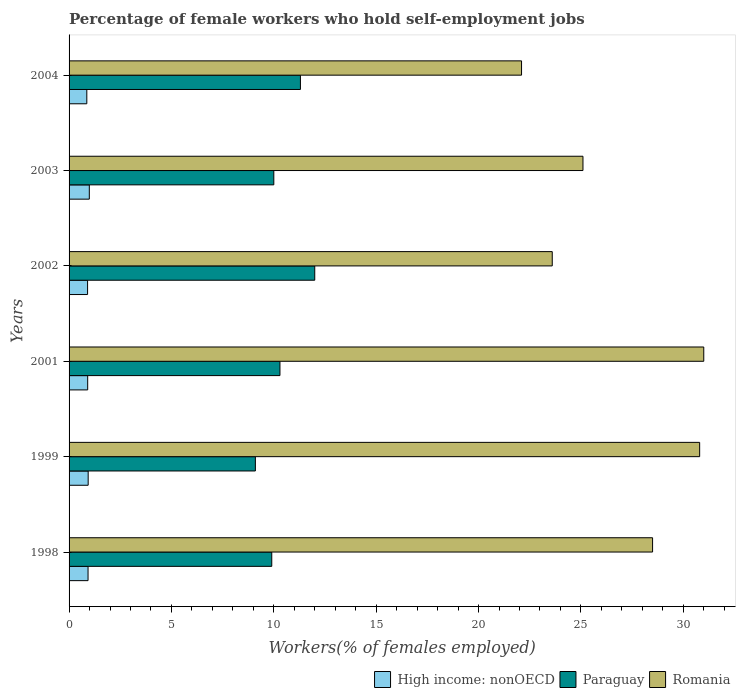Are the number of bars per tick equal to the number of legend labels?
Provide a short and direct response. Yes. How many bars are there on the 4th tick from the top?
Offer a very short reply. 3. What is the label of the 2nd group of bars from the top?
Offer a terse response. 2003. What is the percentage of self-employed female workers in Paraguay in 1999?
Provide a succinct answer. 9.1. Across all years, what is the maximum percentage of self-employed female workers in High income: nonOECD?
Give a very brief answer. 0.99. Across all years, what is the minimum percentage of self-employed female workers in High income: nonOECD?
Keep it short and to the point. 0.87. In which year was the percentage of self-employed female workers in Paraguay maximum?
Keep it short and to the point. 2002. What is the total percentage of self-employed female workers in Romania in the graph?
Offer a terse response. 161.1. What is the difference between the percentage of self-employed female workers in High income: nonOECD in 2002 and that in 2004?
Your answer should be compact. 0.04. What is the difference between the percentage of self-employed female workers in Paraguay in 1999 and the percentage of self-employed female workers in High income: nonOECD in 2001?
Your answer should be very brief. 8.19. What is the average percentage of self-employed female workers in High income: nonOECD per year?
Provide a succinct answer. 0.92. In the year 2003, what is the difference between the percentage of self-employed female workers in High income: nonOECD and percentage of self-employed female workers in Paraguay?
Your response must be concise. -9.01. In how many years, is the percentage of self-employed female workers in Romania greater than 18 %?
Offer a very short reply. 6. What is the ratio of the percentage of self-employed female workers in Paraguay in 1999 to that in 2003?
Offer a terse response. 0.91. What is the difference between the highest and the second highest percentage of self-employed female workers in Paraguay?
Your response must be concise. 0.7. What is the difference between the highest and the lowest percentage of self-employed female workers in Romania?
Your answer should be compact. 8.9. In how many years, is the percentage of self-employed female workers in Paraguay greater than the average percentage of self-employed female workers in Paraguay taken over all years?
Your answer should be very brief. 2. Is the sum of the percentage of self-employed female workers in High income: nonOECD in 2002 and 2003 greater than the maximum percentage of self-employed female workers in Paraguay across all years?
Offer a terse response. No. What does the 1st bar from the top in 2004 represents?
Your answer should be very brief. Romania. What does the 1st bar from the bottom in 1998 represents?
Give a very brief answer. High income: nonOECD. Is it the case that in every year, the sum of the percentage of self-employed female workers in Romania and percentage of self-employed female workers in Paraguay is greater than the percentage of self-employed female workers in High income: nonOECD?
Give a very brief answer. Yes. How many bars are there?
Keep it short and to the point. 18. Are all the bars in the graph horizontal?
Make the answer very short. Yes. What is the difference between two consecutive major ticks on the X-axis?
Your response must be concise. 5. Does the graph contain any zero values?
Give a very brief answer. No. Does the graph contain grids?
Provide a succinct answer. No. How many legend labels are there?
Make the answer very short. 3. How are the legend labels stacked?
Provide a short and direct response. Horizontal. What is the title of the graph?
Provide a succinct answer. Percentage of female workers who hold self-employment jobs. What is the label or title of the X-axis?
Provide a succinct answer. Workers(% of females employed). What is the label or title of the Y-axis?
Give a very brief answer. Years. What is the Workers(% of females employed) of High income: nonOECD in 1998?
Your answer should be compact. 0.93. What is the Workers(% of females employed) in Paraguay in 1998?
Offer a very short reply. 9.9. What is the Workers(% of females employed) in Romania in 1998?
Keep it short and to the point. 28.5. What is the Workers(% of females employed) of High income: nonOECD in 1999?
Make the answer very short. 0.93. What is the Workers(% of females employed) in Paraguay in 1999?
Make the answer very short. 9.1. What is the Workers(% of females employed) of Romania in 1999?
Ensure brevity in your answer.  30.8. What is the Workers(% of females employed) of High income: nonOECD in 2001?
Offer a very short reply. 0.91. What is the Workers(% of females employed) of Paraguay in 2001?
Make the answer very short. 10.3. What is the Workers(% of females employed) in High income: nonOECD in 2002?
Ensure brevity in your answer.  0.9. What is the Workers(% of females employed) in Romania in 2002?
Offer a terse response. 23.6. What is the Workers(% of females employed) of High income: nonOECD in 2003?
Your response must be concise. 0.99. What is the Workers(% of females employed) of Paraguay in 2003?
Your answer should be very brief. 10. What is the Workers(% of females employed) of Romania in 2003?
Ensure brevity in your answer.  25.1. What is the Workers(% of females employed) of High income: nonOECD in 2004?
Your answer should be very brief. 0.87. What is the Workers(% of females employed) of Paraguay in 2004?
Give a very brief answer. 11.3. What is the Workers(% of females employed) in Romania in 2004?
Keep it short and to the point. 22.1. Across all years, what is the maximum Workers(% of females employed) in High income: nonOECD?
Give a very brief answer. 0.99. Across all years, what is the maximum Workers(% of females employed) in Paraguay?
Your response must be concise. 12. Across all years, what is the maximum Workers(% of females employed) in Romania?
Provide a succinct answer. 31. Across all years, what is the minimum Workers(% of females employed) in High income: nonOECD?
Provide a succinct answer. 0.87. Across all years, what is the minimum Workers(% of females employed) in Paraguay?
Your answer should be compact. 9.1. Across all years, what is the minimum Workers(% of females employed) in Romania?
Provide a succinct answer. 22.1. What is the total Workers(% of females employed) in High income: nonOECD in the graph?
Offer a terse response. 5.53. What is the total Workers(% of females employed) in Paraguay in the graph?
Keep it short and to the point. 62.6. What is the total Workers(% of females employed) in Romania in the graph?
Offer a very short reply. 161.1. What is the difference between the Workers(% of females employed) of High income: nonOECD in 1998 and that in 1999?
Keep it short and to the point. -0.01. What is the difference between the Workers(% of females employed) in High income: nonOECD in 1998 and that in 2001?
Your answer should be compact. 0.02. What is the difference between the Workers(% of females employed) of Paraguay in 1998 and that in 2001?
Keep it short and to the point. -0.4. What is the difference between the Workers(% of females employed) of High income: nonOECD in 1998 and that in 2002?
Provide a short and direct response. 0.02. What is the difference between the Workers(% of females employed) of Romania in 1998 and that in 2002?
Ensure brevity in your answer.  4.9. What is the difference between the Workers(% of females employed) in High income: nonOECD in 1998 and that in 2003?
Offer a very short reply. -0.06. What is the difference between the Workers(% of females employed) in High income: nonOECD in 1998 and that in 2004?
Offer a very short reply. 0.06. What is the difference between the Workers(% of females employed) of Paraguay in 1998 and that in 2004?
Keep it short and to the point. -1.4. What is the difference between the Workers(% of females employed) in High income: nonOECD in 1999 and that in 2001?
Provide a succinct answer. 0.02. What is the difference between the Workers(% of females employed) of Romania in 1999 and that in 2001?
Offer a terse response. -0.2. What is the difference between the Workers(% of females employed) in High income: nonOECD in 1999 and that in 2002?
Offer a very short reply. 0.03. What is the difference between the Workers(% of females employed) in Romania in 1999 and that in 2002?
Offer a very short reply. 7.2. What is the difference between the Workers(% of females employed) in High income: nonOECD in 1999 and that in 2003?
Your answer should be very brief. -0.06. What is the difference between the Workers(% of females employed) in High income: nonOECD in 1999 and that in 2004?
Your answer should be very brief. 0.07. What is the difference between the Workers(% of females employed) in Paraguay in 1999 and that in 2004?
Provide a succinct answer. -2.2. What is the difference between the Workers(% of females employed) of High income: nonOECD in 2001 and that in 2002?
Provide a succinct answer. 0.01. What is the difference between the Workers(% of females employed) of Paraguay in 2001 and that in 2002?
Ensure brevity in your answer.  -1.7. What is the difference between the Workers(% of females employed) in Romania in 2001 and that in 2002?
Make the answer very short. 7.4. What is the difference between the Workers(% of females employed) of High income: nonOECD in 2001 and that in 2003?
Keep it short and to the point. -0.08. What is the difference between the Workers(% of females employed) in Paraguay in 2001 and that in 2003?
Keep it short and to the point. 0.3. What is the difference between the Workers(% of females employed) of High income: nonOECD in 2001 and that in 2004?
Offer a terse response. 0.04. What is the difference between the Workers(% of females employed) in Paraguay in 2001 and that in 2004?
Your answer should be compact. -1. What is the difference between the Workers(% of females employed) of Romania in 2001 and that in 2004?
Offer a terse response. 8.9. What is the difference between the Workers(% of females employed) in High income: nonOECD in 2002 and that in 2003?
Keep it short and to the point. -0.08. What is the difference between the Workers(% of females employed) in Paraguay in 2002 and that in 2003?
Make the answer very short. 2. What is the difference between the Workers(% of females employed) of Romania in 2002 and that in 2003?
Provide a succinct answer. -1.5. What is the difference between the Workers(% of females employed) of High income: nonOECD in 2002 and that in 2004?
Keep it short and to the point. 0.04. What is the difference between the Workers(% of females employed) in Paraguay in 2002 and that in 2004?
Make the answer very short. 0.7. What is the difference between the Workers(% of females employed) of High income: nonOECD in 2003 and that in 2004?
Offer a very short reply. 0.12. What is the difference between the Workers(% of females employed) of High income: nonOECD in 1998 and the Workers(% of females employed) of Paraguay in 1999?
Provide a short and direct response. -8.17. What is the difference between the Workers(% of females employed) in High income: nonOECD in 1998 and the Workers(% of females employed) in Romania in 1999?
Keep it short and to the point. -29.87. What is the difference between the Workers(% of females employed) in Paraguay in 1998 and the Workers(% of females employed) in Romania in 1999?
Provide a short and direct response. -20.9. What is the difference between the Workers(% of females employed) of High income: nonOECD in 1998 and the Workers(% of females employed) of Paraguay in 2001?
Keep it short and to the point. -9.37. What is the difference between the Workers(% of females employed) in High income: nonOECD in 1998 and the Workers(% of females employed) in Romania in 2001?
Your answer should be compact. -30.07. What is the difference between the Workers(% of females employed) in Paraguay in 1998 and the Workers(% of females employed) in Romania in 2001?
Ensure brevity in your answer.  -21.1. What is the difference between the Workers(% of females employed) of High income: nonOECD in 1998 and the Workers(% of females employed) of Paraguay in 2002?
Offer a terse response. -11.07. What is the difference between the Workers(% of females employed) of High income: nonOECD in 1998 and the Workers(% of females employed) of Romania in 2002?
Make the answer very short. -22.67. What is the difference between the Workers(% of females employed) of Paraguay in 1998 and the Workers(% of females employed) of Romania in 2002?
Your answer should be very brief. -13.7. What is the difference between the Workers(% of females employed) of High income: nonOECD in 1998 and the Workers(% of females employed) of Paraguay in 2003?
Your answer should be very brief. -9.07. What is the difference between the Workers(% of females employed) in High income: nonOECD in 1998 and the Workers(% of females employed) in Romania in 2003?
Give a very brief answer. -24.17. What is the difference between the Workers(% of females employed) in Paraguay in 1998 and the Workers(% of females employed) in Romania in 2003?
Provide a short and direct response. -15.2. What is the difference between the Workers(% of females employed) of High income: nonOECD in 1998 and the Workers(% of females employed) of Paraguay in 2004?
Your response must be concise. -10.37. What is the difference between the Workers(% of females employed) in High income: nonOECD in 1998 and the Workers(% of females employed) in Romania in 2004?
Your answer should be compact. -21.17. What is the difference between the Workers(% of females employed) of Paraguay in 1998 and the Workers(% of females employed) of Romania in 2004?
Offer a terse response. -12.2. What is the difference between the Workers(% of females employed) in High income: nonOECD in 1999 and the Workers(% of females employed) in Paraguay in 2001?
Your response must be concise. -9.37. What is the difference between the Workers(% of females employed) of High income: nonOECD in 1999 and the Workers(% of females employed) of Romania in 2001?
Ensure brevity in your answer.  -30.07. What is the difference between the Workers(% of females employed) of Paraguay in 1999 and the Workers(% of females employed) of Romania in 2001?
Offer a terse response. -21.9. What is the difference between the Workers(% of females employed) in High income: nonOECD in 1999 and the Workers(% of females employed) in Paraguay in 2002?
Your response must be concise. -11.07. What is the difference between the Workers(% of females employed) of High income: nonOECD in 1999 and the Workers(% of females employed) of Romania in 2002?
Your answer should be very brief. -22.67. What is the difference between the Workers(% of females employed) in High income: nonOECD in 1999 and the Workers(% of females employed) in Paraguay in 2003?
Give a very brief answer. -9.07. What is the difference between the Workers(% of females employed) of High income: nonOECD in 1999 and the Workers(% of females employed) of Romania in 2003?
Provide a short and direct response. -24.17. What is the difference between the Workers(% of females employed) of High income: nonOECD in 1999 and the Workers(% of females employed) of Paraguay in 2004?
Offer a terse response. -10.37. What is the difference between the Workers(% of females employed) of High income: nonOECD in 1999 and the Workers(% of females employed) of Romania in 2004?
Your response must be concise. -21.17. What is the difference between the Workers(% of females employed) of High income: nonOECD in 2001 and the Workers(% of females employed) of Paraguay in 2002?
Your response must be concise. -11.09. What is the difference between the Workers(% of females employed) of High income: nonOECD in 2001 and the Workers(% of females employed) of Romania in 2002?
Offer a terse response. -22.69. What is the difference between the Workers(% of females employed) of Paraguay in 2001 and the Workers(% of females employed) of Romania in 2002?
Keep it short and to the point. -13.3. What is the difference between the Workers(% of females employed) of High income: nonOECD in 2001 and the Workers(% of females employed) of Paraguay in 2003?
Make the answer very short. -9.09. What is the difference between the Workers(% of females employed) of High income: nonOECD in 2001 and the Workers(% of females employed) of Romania in 2003?
Your answer should be very brief. -24.19. What is the difference between the Workers(% of females employed) of Paraguay in 2001 and the Workers(% of females employed) of Romania in 2003?
Offer a very short reply. -14.8. What is the difference between the Workers(% of females employed) in High income: nonOECD in 2001 and the Workers(% of females employed) in Paraguay in 2004?
Your answer should be compact. -10.39. What is the difference between the Workers(% of females employed) of High income: nonOECD in 2001 and the Workers(% of females employed) of Romania in 2004?
Keep it short and to the point. -21.19. What is the difference between the Workers(% of females employed) in High income: nonOECD in 2002 and the Workers(% of females employed) in Paraguay in 2003?
Offer a terse response. -9.1. What is the difference between the Workers(% of females employed) in High income: nonOECD in 2002 and the Workers(% of females employed) in Romania in 2003?
Your answer should be very brief. -24.2. What is the difference between the Workers(% of females employed) of High income: nonOECD in 2002 and the Workers(% of females employed) of Paraguay in 2004?
Ensure brevity in your answer.  -10.4. What is the difference between the Workers(% of females employed) in High income: nonOECD in 2002 and the Workers(% of females employed) in Romania in 2004?
Offer a terse response. -21.2. What is the difference between the Workers(% of females employed) in High income: nonOECD in 2003 and the Workers(% of females employed) in Paraguay in 2004?
Offer a very short reply. -10.31. What is the difference between the Workers(% of females employed) of High income: nonOECD in 2003 and the Workers(% of females employed) of Romania in 2004?
Make the answer very short. -21.11. What is the difference between the Workers(% of females employed) in Paraguay in 2003 and the Workers(% of females employed) in Romania in 2004?
Provide a short and direct response. -12.1. What is the average Workers(% of females employed) in High income: nonOECD per year?
Your response must be concise. 0.92. What is the average Workers(% of females employed) in Paraguay per year?
Offer a very short reply. 10.43. What is the average Workers(% of females employed) in Romania per year?
Offer a very short reply. 26.85. In the year 1998, what is the difference between the Workers(% of females employed) in High income: nonOECD and Workers(% of females employed) in Paraguay?
Your answer should be compact. -8.97. In the year 1998, what is the difference between the Workers(% of females employed) in High income: nonOECD and Workers(% of females employed) in Romania?
Your answer should be very brief. -27.57. In the year 1998, what is the difference between the Workers(% of females employed) of Paraguay and Workers(% of females employed) of Romania?
Provide a short and direct response. -18.6. In the year 1999, what is the difference between the Workers(% of females employed) of High income: nonOECD and Workers(% of females employed) of Paraguay?
Your answer should be very brief. -8.17. In the year 1999, what is the difference between the Workers(% of females employed) in High income: nonOECD and Workers(% of females employed) in Romania?
Your response must be concise. -29.87. In the year 1999, what is the difference between the Workers(% of females employed) in Paraguay and Workers(% of females employed) in Romania?
Your answer should be very brief. -21.7. In the year 2001, what is the difference between the Workers(% of females employed) in High income: nonOECD and Workers(% of females employed) in Paraguay?
Provide a succinct answer. -9.39. In the year 2001, what is the difference between the Workers(% of females employed) in High income: nonOECD and Workers(% of females employed) in Romania?
Provide a succinct answer. -30.09. In the year 2001, what is the difference between the Workers(% of females employed) of Paraguay and Workers(% of females employed) of Romania?
Give a very brief answer. -20.7. In the year 2002, what is the difference between the Workers(% of females employed) of High income: nonOECD and Workers(% of females employed) of Paraguay?
Offer a very short reply. -11.1. In the year 2002, what is the difference between the Workers(% of females employed) in High income: nonOECD and Workers(% of females employed) in Romania?
Provide a short and direct response. -22.7. In the year 2002, what is the difference between the Workers(% of females employed) of Paraguay and Workers(% of females employed) of Romania?
Ensure brevity in your answer.  -11.6. In the year 2003, what is the difference between the Workers(% of females employed) of High income: nonOECD and Workers(% of females employed) of Paraguay?
Your answer should be compact. -9.01. In the year 2003, what is the difference between the Workers(% of females employed) in High income: nonOECD and Workers(% of females employed) in Romania?
Offer a terse response. -24.11. In the year 2003, what is the difference between the Workers(% of females employed) of Paraguay and Workers(% of females employed) of Romania?
Provide a short and direct response. -15.1. In the year 2004, what is the difference between the Workers(% of females employed) of High income: nonOECD and Workers(% of females employed) of Paraguay?
Provide a short and direct response. -10.43. In the year 2004, what is the difference between the Workers(% of females employed) of High income: nonOECD and Workers(% of females employed) of Romania?
Your answer should be compact. -21.23. In the year 2004, what is the difference between the Workers(% of females employed) in Paraguay and Workers(% of females employed) in Romania?
Provide a succinct answer. -10.8. What is the ratio of the Workers(% of females employed) of Paraguay in 1998 to that in 1999?
Keep it short and to the point. 1.09. What is the ratio of the Workers(% of females employed) in Romania in 1998 to that in 1999?
Offer a terse response. 0.93. What is the ratio of the Workers(% of females employed) of High income: nonOECD in 1998 to that in 2001?
Make the answer very short. 1.02. What is the ratio of the Workers(% of females employed) in Paraguay in 1998 to that in 2001?
Your response must be concise. 0.96. What is the ratio of the Workers(% of females employed) of Romania in 1998 to that in 2001?
Your answer should be compact. 0.92. What is the ratio of the Workers(% of females employed) in High income: nonOECD in 1998 to that in 2002?
Make the answer very short. 1.03. What is the ratio of the Workers(% of females employed) of Paraguay in 1998 to that in 2002?
Offer a very short reply. 0.82. What is the ratio of the Workers(% of females employed) in Romania in 1998 to that in 2002?
Ensure brevity in your answer.  1.21. What is the ratio of the Workers(% of females employed) in Paraguay in 1998 to that in 2003?
Ensure brevity in your answer.  0.99. What is the ratio of the Workers(% of females employed) of Romania in 1998 to that in 2003?
Give a very brief answer. 1.14. What is the ratio of the Workers(% of females employed) in High income: nonOECD in 1998 to that in 2004?
Offer a terse response. 1.07. What is the ratio of the Workers(% of females employed) in Paraguay in 1998 to that in 2004?
Make the answer very short. 0.88. What is the ratio of the Workers(% of females employed) in Romania in 1998 to that in 2004?
Ensure brevity in your answer.  1.29. What is the ratio of the Workers(% of females employed) of High income: nonOECD in 1999 to that in 2001?
Keep it short and to the point. 1.03. What is the ratio of the Workers(% of females employed) in Paraguay in 1999 to that in 2001?
Ensure brevity in your answer.  0.88. What is the ratio of the Workers(% of females employed) in Romania in 1999 to that in 2001?
Offer a very short reply. 0.99. What is the ratio of the Workers(% of females employed) of High income: nonOECD in 1999 to that in 2002?
Your answer should be compact. 1.03. What is the ratio of the Workers(% of females employed) of Paraguay in 1999 to that in 2002?
Provide a succinct answer. 0.76. What is the ratio of the Workers(% of females employed) in Romania in 1999 to that in 2002?
Your answer should be very brief. 1.31. What is the ratio of the Workers(% of females employed) of High income: nonOECD in 1999 to that in 2003?
Your answer should be very brief. 0.94. What is the ratio of the Workers(% of females employed) in Paraguay in 1999 to that in 2003?
Offer a very short reply. 0.91. What is the ratio of the Workers(% of females employed) of Romania in 1999 to that in 2003?
Your response must be concise. 1.23. What is the ratio of the Workers(% of females employed) in High income: nonOECD in 1999 to that in 2004?
Your answer should be very brief. 1.08. What is the ratio of the Workers(% of females employed) in Paraguay in 1999 to that in 2004?
Your answer should be compact. 0.81. What is the ratio of the Workers(% of females employed) in Romania in 1999 to that in 2004?
Provide a short and direct response. 1.39. What is the ratio of the Workers(% of females employed) in High income: nonOECD in 2001 to that in 2002?
Provide a succinct answer. 1.01. What is the ratio of the Workers(% of females employed) in Paraguay in 2001 to that in 2002?
Give a very brief answer. 0.86. What is the ratio of the Workers(% of females employed) in Romania in 2001 to that in 2002?
Give a very brief answer. 1.31. What is the ratio of the Workers(% of females employed) in Paraguay in 2001 to that in 2003?
Your response must be concise. 1.03. What is the ratio of the Workers(% of females employed) in Romania in 2001 to that in 2003?
Offer a very short reply. 1.24. What is the ratio of the Workers(% of females employed) of High income: nonOECD in 2001 to that in 2004?
Make the answer very short. 1.05. What is the ratio of the Workers(% of females employed) in Paraguay in 2001 to that in 2004?
Offer a terse response. 0.91. What is the ratio of the Workers(% of females employed) in Romania in 2001 to that in 2004?
Offer a very short reply. 1.4. What is the ratio of the Workers(% of females employed) in High income: nonOECD in 2002 to that in 2003?
Offer a very short reply. 0.91. What is the ratio of the Workers(% of females employed) of Romania in 2002 to that in 2003?
Your answer should be very brief. 0.94. What is the ratio of the Workers(% of females employed) in High income: nonOECD in 2002 to that in 2004?
Your response must be concise. 1.04. What is the ratio of the Workers(% of females employed) of Paraguay in 2002 to that in 2004?
Provide a short and direct response. 1.06. What is the ratio of the Workers(% of females employed) in Romania in 2002 to that in 2004?
Offer a terse response. 1.07. What is the ratio of the Workers(% of females employed) of High income: nonOECD in 2003 to that in 2004?
Offer a terse response. 1.14. What is the ratio of the Workers(% of females employed) in Paraguay in 2003 to that in 2004?
Give a very brief answer. 0.89. What is the ratio of the Workers(% of females employed) of Romania in 2003 to that in 2004?
Provide a succinct answer. 1.14. What is the difference between the highest and the second highest Workers(% of females employed) of High income: nonOECD?
Offer a very short reply. 0.06. What is the difference between the highest and the second highest Workers(% of females employed) in Paraguay?
Keep it short and to the point. 0.7. What is the difference between the highest and the lowest Workers(% of females employed) of High income: nonOECD?
Ensure brevity in your answer.  0.12. What is the difference between the highest and the lowest Workers(% of females employed) in Romania?
Offer a very short reply. 8.9. 